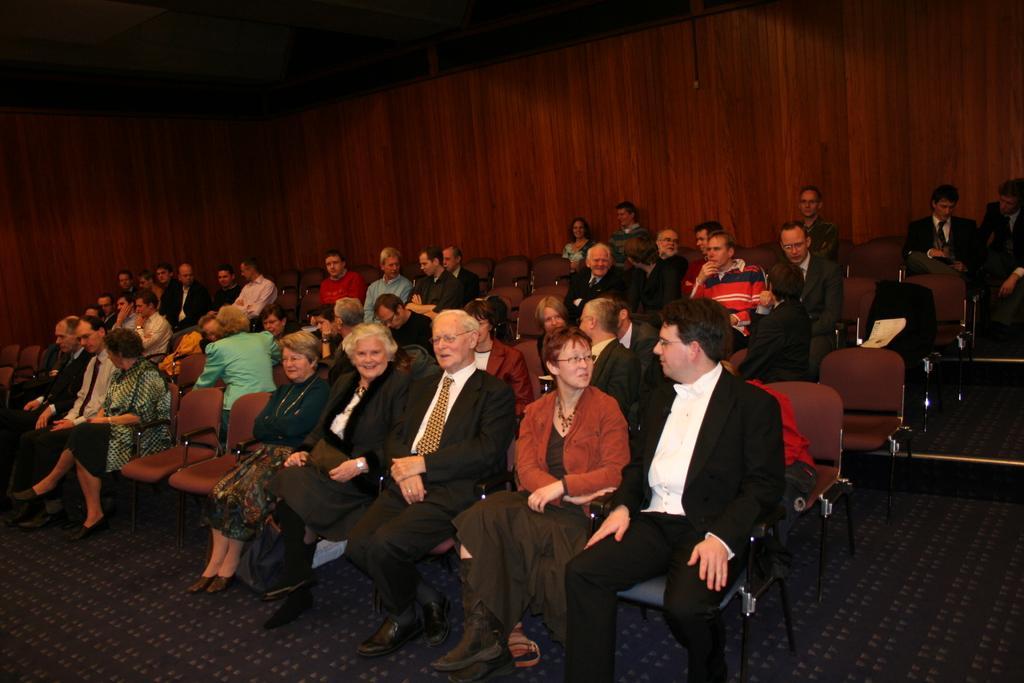How would you summarize this image in a sentence or two? In this image there are people sitting on chairs, in the background there a wooden wall. 